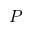<formula> <loc_0><loc_0><loc_500><loc_500>P</formula> 